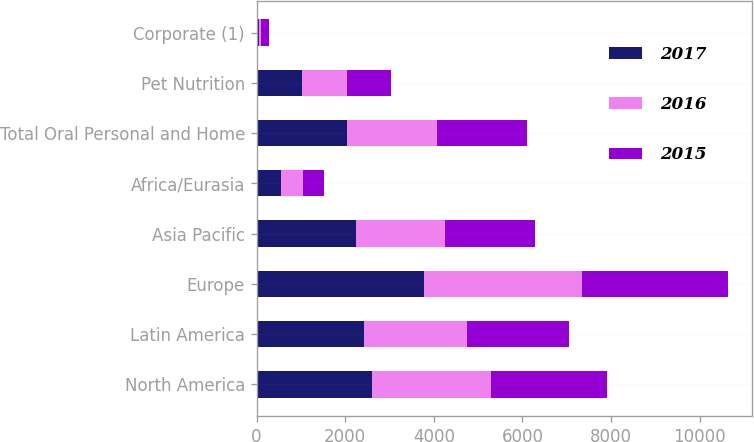<chart> <loc_0><loc_0><loc_500><loc_500><stacked_bar_chart><ecel><fcel>North America<fcel>Latin America<fcel>Europe<fcel>Asia Pacific<fcel>Africa/Eurasia<fcel>Total Oral Personal and Home<fcel>Pet Nutrition<fcel>Corporate (1)<nl><fcel>2017<fcel>2608<fcel>2423<fcel>3781<fcel>2244<fcel>544<fcel>2031<fcel>1026<fcel>50<nl><fcel>2016<fcel>2685<fcel>2314<fcel>3554<fcel>2006<fcel>499<fcel>2031<fcel>1009<fcel>56<nl><fcel>2015<fcel>2622<fcel>2314<fcel>3308<fcel>2031<fcel>476<fcel>2031<fcel>1006<fcel>178<nl></chart> 